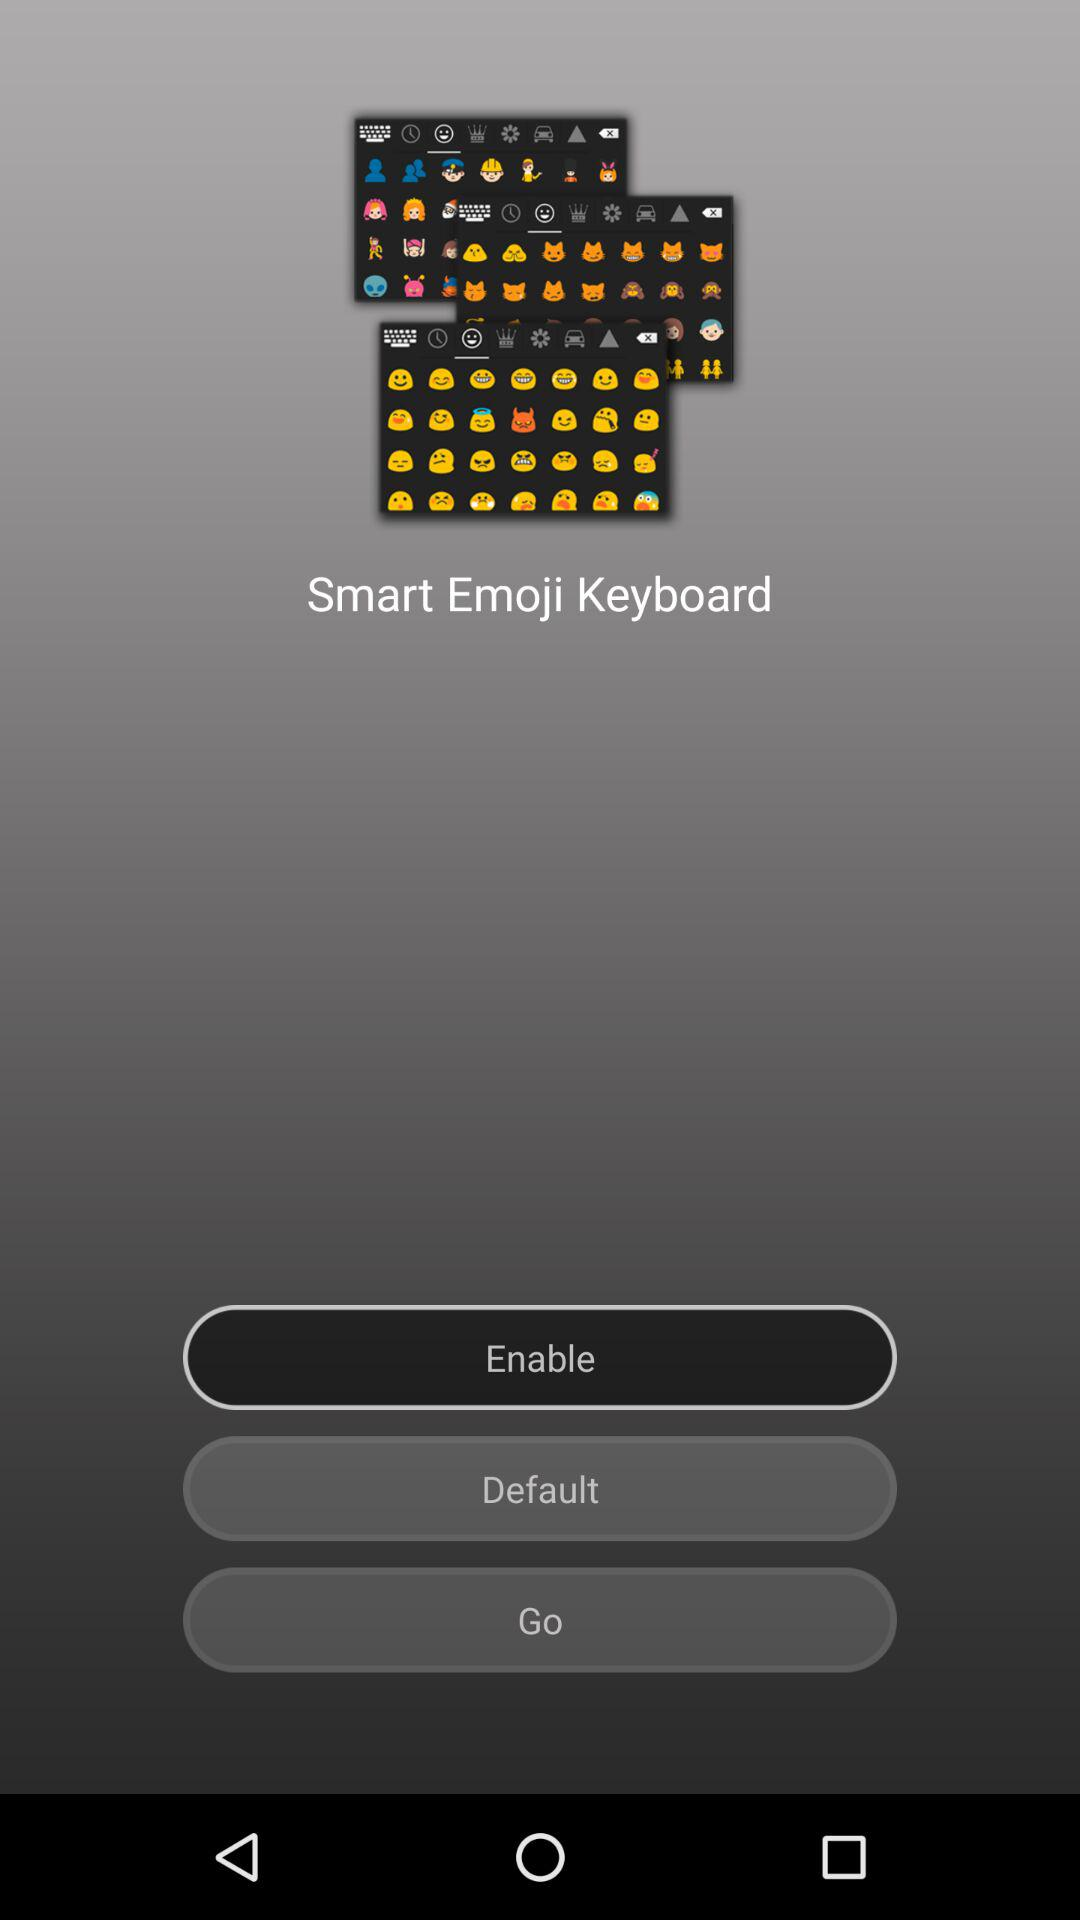What's the status of the "Smart Emoji Keyboard"? The status of the "Smart Emoji Keyboard" is "Enable". 